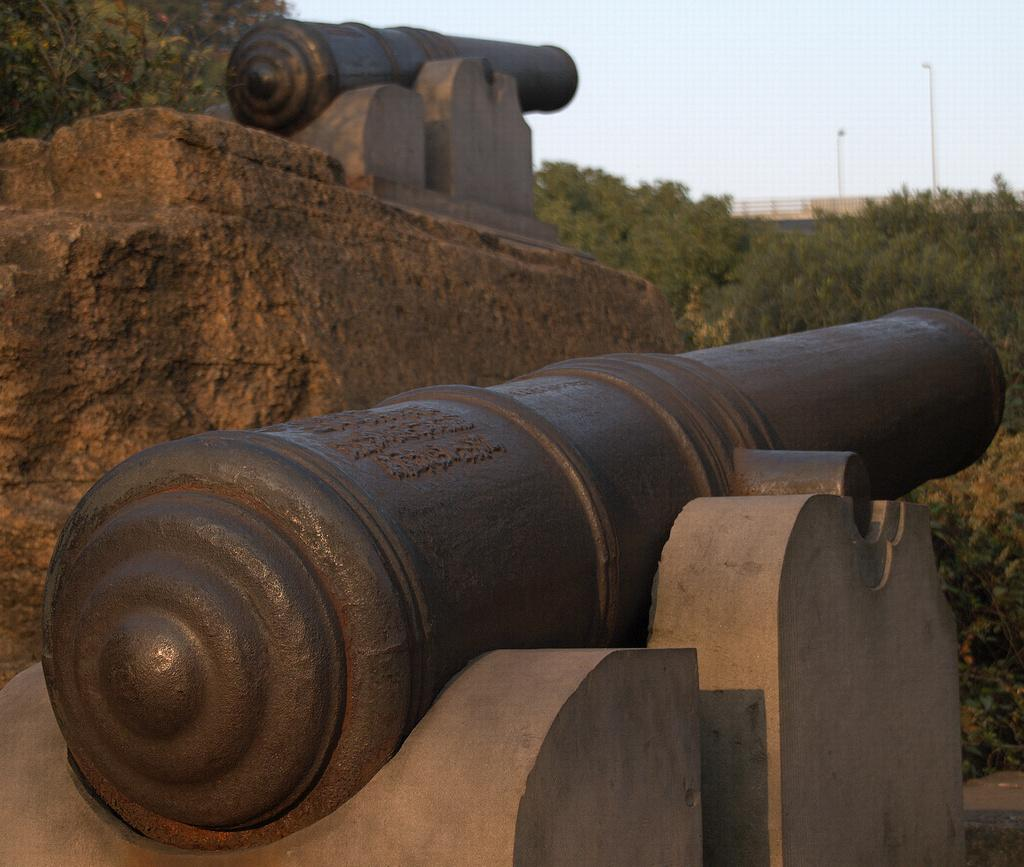What type of artwork can be seen in the image? There are sculptures in the image. What natural elements are present in the image? There are rocks and trees in the image. What man-made structures can be seen in the image? There are poles in the image. What is visible in the background of the image? The sky is visible in the image. Can you see any horns on the sculptures in the image? There is no mention of horns on the sculptures in the image, so we cannot determine if they are present or not. Are there any balls visible in the image? There is no mention of balls in the image, so we cannot determine if they are present or not. 